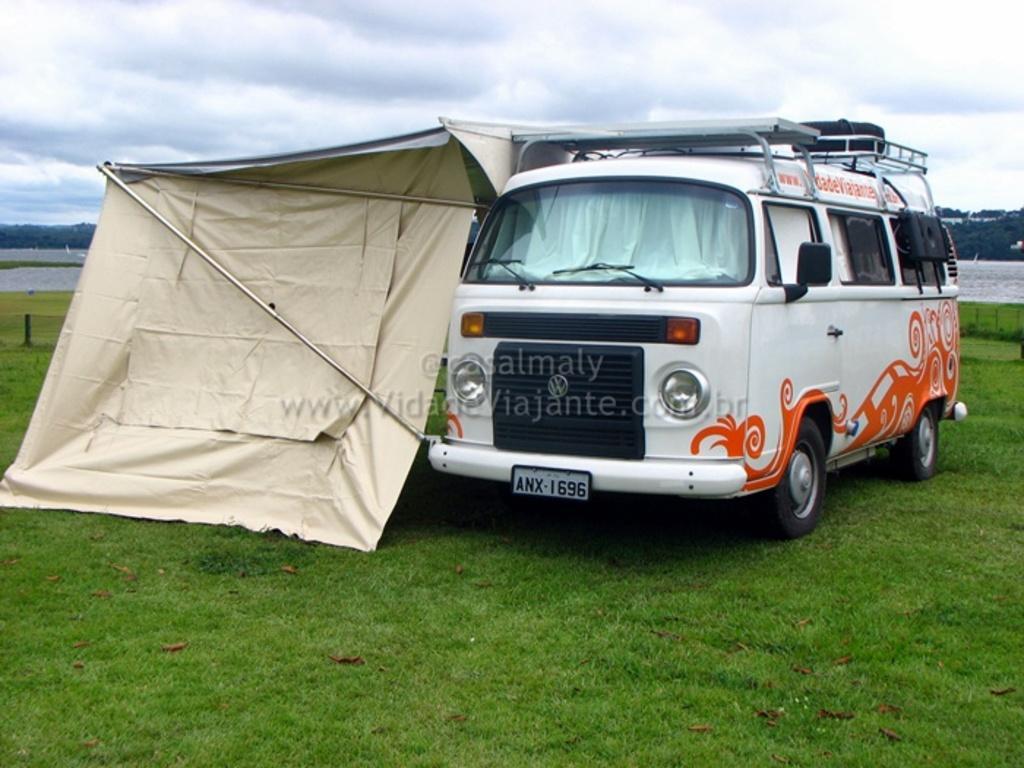Describe this image in one or two sentences. In this picture we can see the grass, vehicle, tent, rods, water, trees, pole and in the background we can see the sky with clouds. 